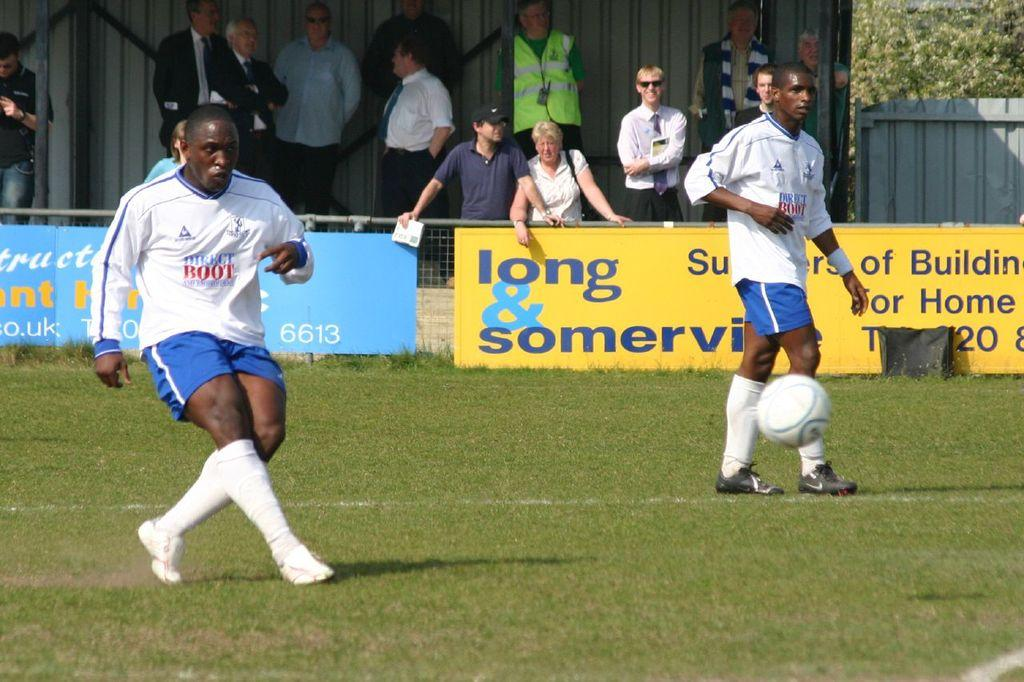<image>
Render a clear and concise summary of the photo. Football players are on a field in front of a yellow banner reading long & somerville. 